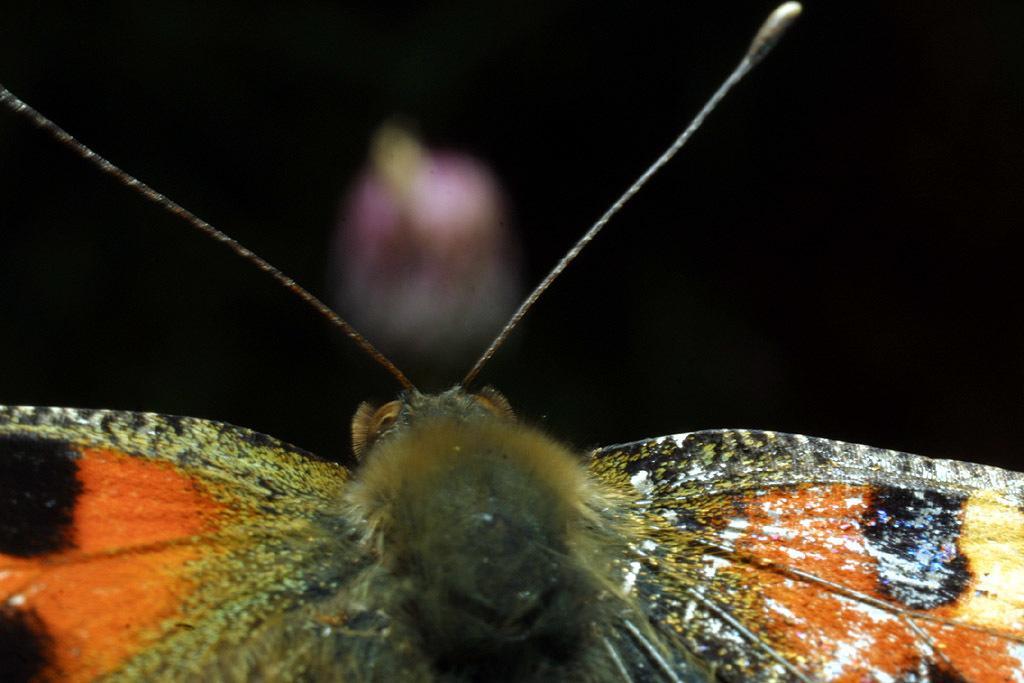Could you give a brief overview of what you see in this image? In this picture we can see an insect and dark background. 